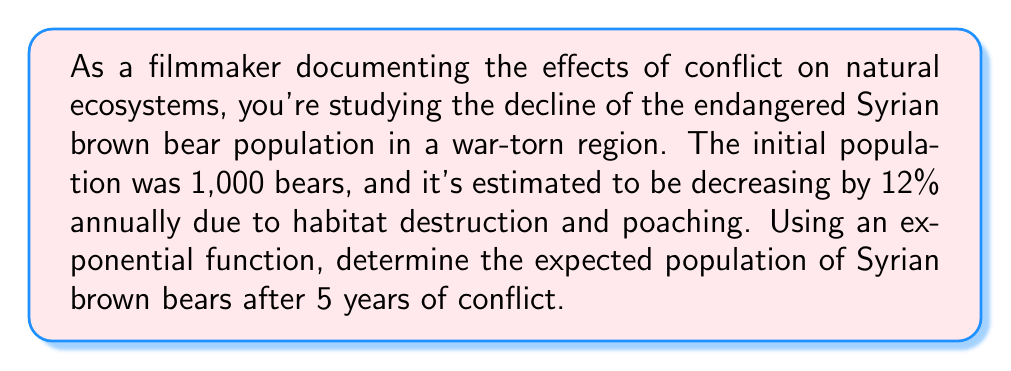Give your solution to this math problem. To solve this problem, we'll use the exponential decay function:

$$P(t) = P_0 \cdot (1-r)^t$$

Where:
$P(t)$ is the population at time $t$
$P_0$ is the initial population
$r$ is the rate of decline (as a decimal)
$t$ is the time in years

Given:
$P_0 = 1000$ (initial population)
$r = 0.12$ (12% annual decline)
$t = 5$ years

Step 1: Substitute the values into the exponential decay function:
$$P(5) = 1000 \cdot (1-0.12)^5$$

Step 2: Simplify the expression inside the parentheses:
$$P(5) = 1000 \cdot (0.88)^5$$

Step 3: Calculate the value of $(0.88)^5$:
$$(0.88)^5 \approx 0.5404$$

Step 4: Multiply by the initial population:
$$P(5) = 1000 \cdot 0.5404 \approx 540.4$$

Step 5: Round to the nearest whole number, as we're dealing with a population of bears:
$$P(5) \approx 540 \text{ bears}$$
Answer: 540 bears 